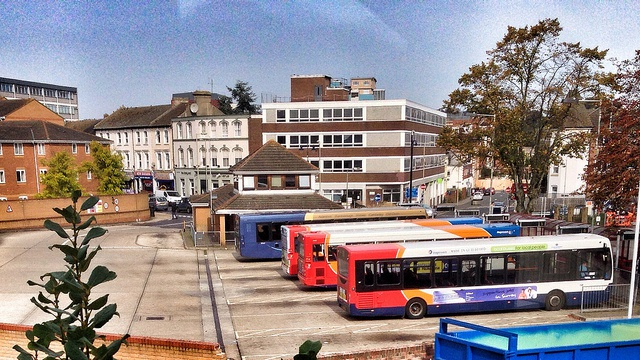Describe the objects in this image and their specific colors. I can see bus in gray, black, white, and navy tones, truck in gray, blue, darkblue, turquoise, and lightgreen tones, bus in gray, white, red, lightpink, and black tones, bus in gray, black, blue, purple, and darkgray tones, and bus in gray, white, lightpink, red, and salmon tones in this image. 